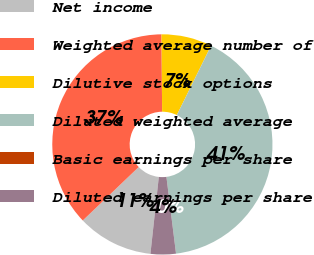Convert chart. <chart><loc_0><loc_0><loc_500><loc_500><pie_chart><fcel>Net income<fcel>Weighted average number of<fcel>Dilutive stock options<fcel>Diluted weighted average<fcel>Basic earnings per share<fcel>Diluted earnings per share<nl><fcel>11.13%<fcel>37.01%<fcel>7.42%<fcel>40.72%<fcel>0.0%<fcel>3.71%<nl></chart> 